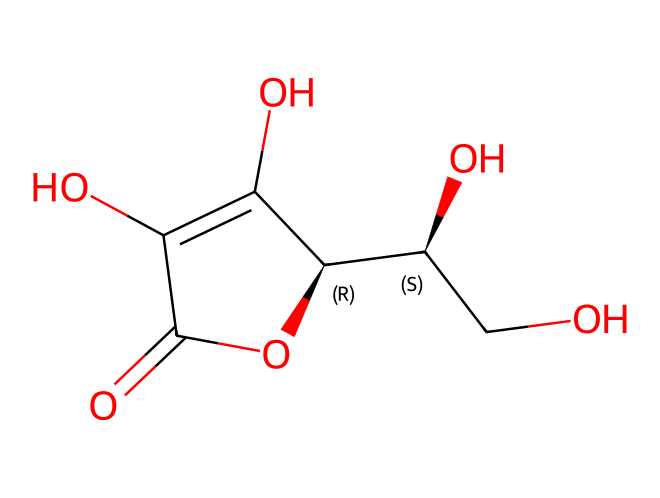What is the molecular formula of ascorbic acid? The SMILES structure can be converted to its molecular formula by analyzing the atoms present. Count the carbon (C), hydrogen (H), and oxygen (O) atoms from the representation. The structure indicates there are 6 carbons, 8 hydrogens, and 6 oxygens, leading to the formula C6H8O6.
Answer: C6H8O6 How many stereocenters are present in ascorbic acid? By examining the carbon atoms in the SMILES, identify which ones are attached to four different substituents. The structure reveals two carbon atoms are stereocenters, which can be confirmed by the specific configuration of substituents around them.
Answer: 2 What functional groups are present in ascorbic acid? Analyzing the structure shows several functional groups. The presence of hydroxyl (–OH) groups and a carbonyl (C=O) group indicates that this molecule contains alcohols and a ketone. Counting these yields the functional groups present.
Answer: hydroxyl, carbonyl Is ascorbic acid a reducing or oxidizing agent? Reviewing the function of ascorbic acid, it acts as a reducing agent in food preservation. This is derived from its ability to donate electrons, which is characteristic behavior of reducing agents, especially in the context of antioxidants.
Answer: reducing agent What role does ascorbic acid play in food preservation? The role can be derived from its properties as an oxidizing agent while actively reducing other compounds. Ascorbic acid protects food from oxidation, helping preserve color and flavor by inhibiting enzymatic browning reactions.
Answer: antioxidant 